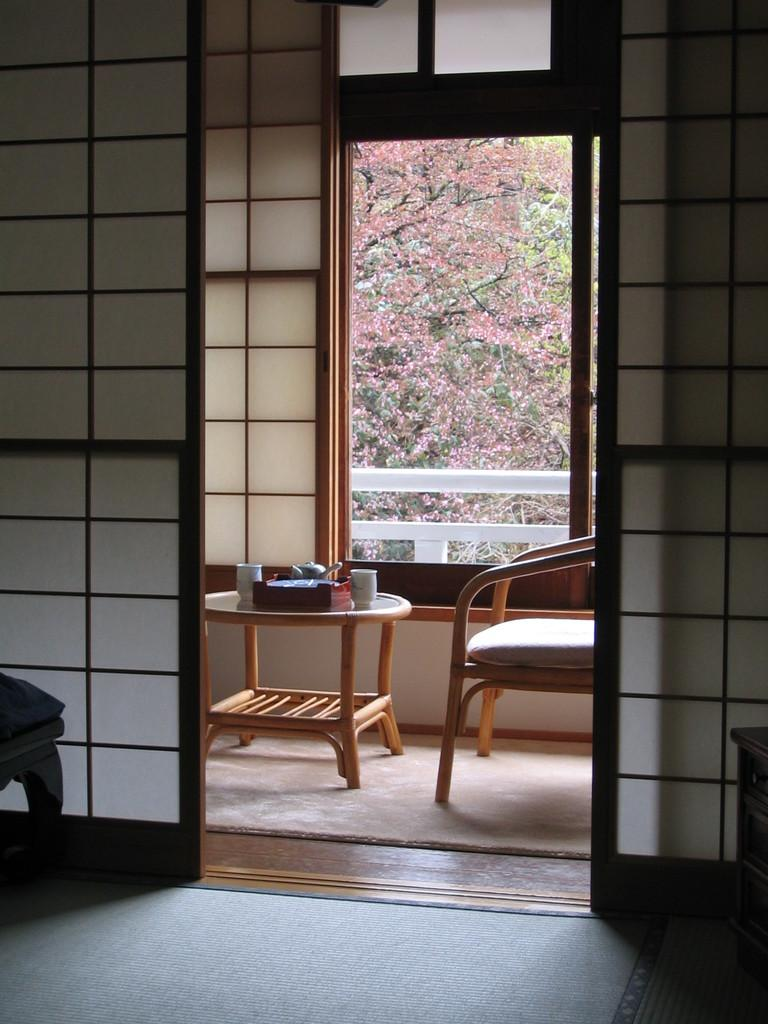What is depicted on the floor in the image? There is a representation of Mars on the floor. What type of furniture is present in the image? There is a chair in the image. What is used for heating water in the image? There is a kettle in the image. What can be used for drinking hot beverages in the image? There are cups in the image. What is placed on the table in the image? There is a box on the table. What type of structure is visible in the image? There are walls visible in the image. What allows natural light to enter the room in the image? There is a window in the image. What type of object can be seen through the window in the image? There is an object (tree) visible through the window. Where is the pail located in the image? There is no pail present in the image. What type of plant is growing in the clover field visible through the window? There is no clover field visible through the window, and no plants are mentioned in the image. What is the rake used for in the image? There is no rake present in the image. 